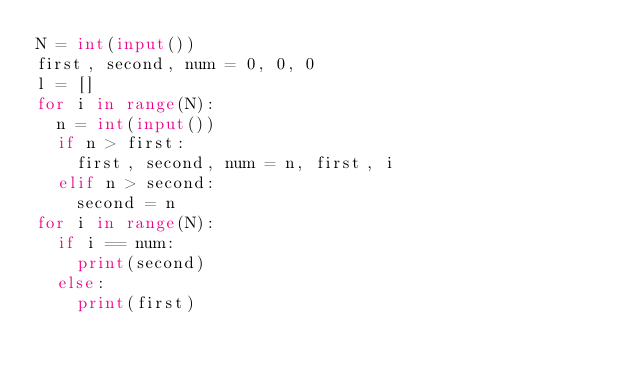<code> <loc_0><loc_0><loc_500><loc_500><_Python_>N = int(input())
first, second, num = 0, 0, 0
l = []
for i in range(N):
	n = int(input())
	if n > first:
		first, second, num = n, first, i
	elif n > second:
		second = n
for i in range(N):
	if i == num:
		print(second)
	else:
		print(first)</code> 